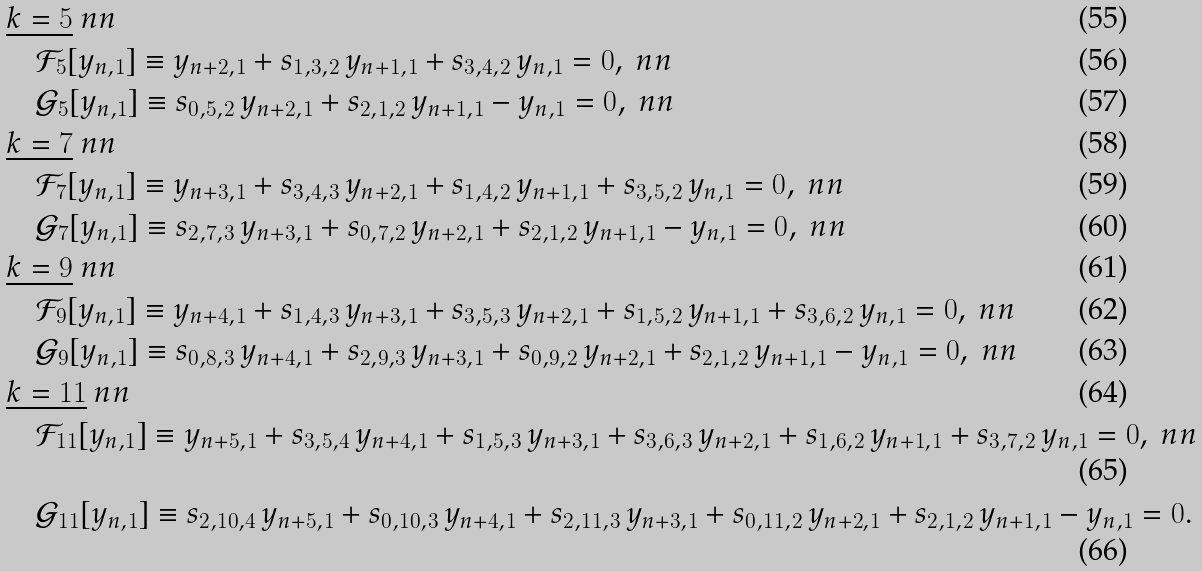<formula> <loc_0><loc_0><loc_500><loc_500>& \underline { \text {$k=5$} } \ n n \\ & \quad \mathcal { F } _ { 5 } [ y _ { n , 1 } ] \equiv y _ { n + 2 , 1 } + s _ { 1 , 3 , 2 } \, y _ { n + 1 , 1 } + s _ { 3 , 4 , 2 } \, y _ { n , 1 } = 0 , \ n n \\ & \quad \mathcal { G } _ { 5 } [ y _ { n , 1 } ] \equiv s _ { 0 , 5 , 2 } \, y _ { n + 2 , 1 } + s _ { 2 , 1 , 2 } \, y _ { n + 1 , 1 } - y _ { n , 1 } = 0 , \ n n \\ & \underline { \text {$k=7$} } \ n n \\ & \quad \mathcal { F } _ { 7 } [ y _ { n , 1 } ] \equiv y _ { n + 3 , 1 } + s _ { 3 , 4 , 3 } \, y _ { n + 2 , 1 } + s _ { 1 , 4 , 2 } \, y _ { n + 1 , 1 } + s _ { 3 , 5 , 2 } \, y _ { n , 1 } = 0 , \ n n \\ & \quad \mathcal { G } _ { 7 } [ y _ { n , 1 } ] \equiv s _ { 2 , 7 , 3 } \, y _ { n + 3 , 1 } + s _ { 0 , 7 , 2 } \, y _ { n + 2 , 1 } + s _ { 2 , 1 , 2 } \, y _ { n + 1 , 1 } - y _ { n , 1 } = 0 , \ n n \\ & \underline { \text {$k=9$} } \ n n \\ & \quad \mathcal { F } _ { 9 } [ y _ { n , 1 } ] \equiv y _ { n + 4 , 1 } + s _ { 1 , 4 , 3 } \, y _ { n + 3 , 1 } + s _ { 3 , 5 , 3 } \, y _ { n + 2 , 1 } + s _ { 1 , 5 , 2 } \, y _ { n + 1 , 1 } + s _ { 3 , 6 , 2 } \, y _ { n , 1 } = 0 , \ n n \\ & \quad \mathcal { G } _ { 9 } [ y _ { n , 1 } ] \equiv s _ { 0 , 8 , 3 } \, y _ { n + 4 , 1 } + s _ { 2 , 9 , 3 } \, y _ { n + 3 , 1 } + s _ { 0 , 9 , 2 } \, y _ { n + 2 , 1 } + s _ { 2 , 1 , 2 } \, y _ { n + 1 , 1 } - y _ { n , 1 } = 0 , \ n n \\ & \underline { \text {$k=11$} } \ n n \\ & \quad \mathcal { F } _ { 1 1 } [ y _ { n , 1 } ] \equiv y _ { n + 5 , 1 } + s _ { 3 , 5 , 4 } \, y _ { n + 4 , 1 } + s _ { 1 , 5 , 3 } \, y _ { n + 3 , 1 } + s _ { 3 , 6 , 3 } \, y _ { n + 2 , 1 } + s _ { 1 , 6 , 2 } \, y _ { n + 1 , 1 } + s _ { 3 , 7 , 2 } \, y _ { n , 1 } = 0 , \ n n \\ & \quad \mathcal { G } _ { 1 1 } [ y _ { n , 1 } ] \equiv s _ { 2 , 1 0 , 4 } \, y _ { n + 5 , 1 } + s _ { 0 , 1 0 , 3 } \, y _ { n + 4 , 1 } + s _ { 2 , 1 1 , 3 } \, y _ { n + 3 , 1 } + s _ { 0 , 1 1 , 2 } \, y _ { n + 2 , 1 } + s _ { 2 , 1 , 2 } \, y _ { n + 1 , 1 } - y _ { n , 1 } = 0 .</formula> 